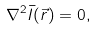<formula> <loc_0><loc_0><loc_500><loc_500>\nabla ^ { 2 } \bar { I } ( \vec { r } ) = 0 ,</formula> 